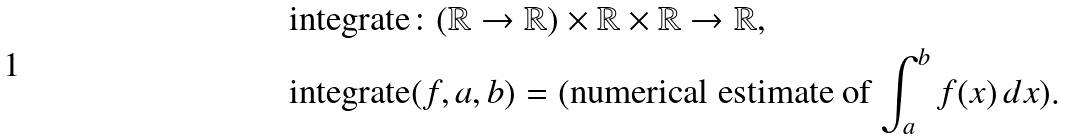Convert formula to latex. <formula><loc_0><loc_0><loc_500><loc_500>& \text {integrate} \colon ( \mathbb { R } \to \mathbb { R } ) \times \mathbb { R } \times \mathbb { R } \to \mathbb { R } , \\ & \text {integrate} ( f , a , b ) = ( \text {numerical estimate of $\int_{a}^{b} f(x) \, dx$} ) .</formula> 